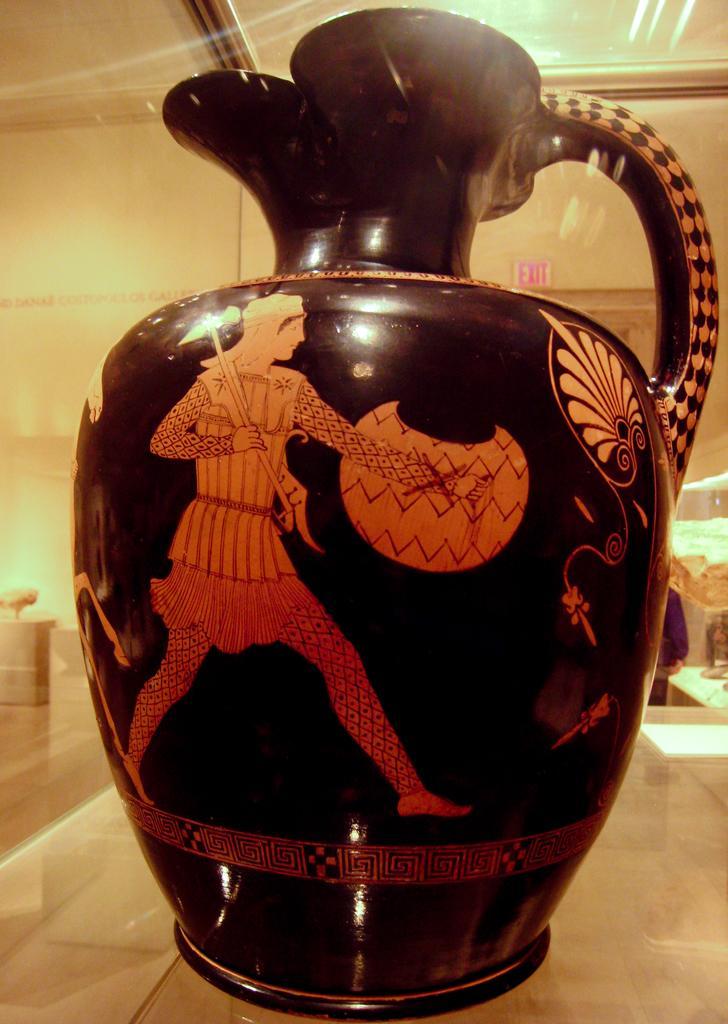In one or two sentences, can you explain what this image depicts? As we can see in the image there is a pot and in the background there is a wall. 